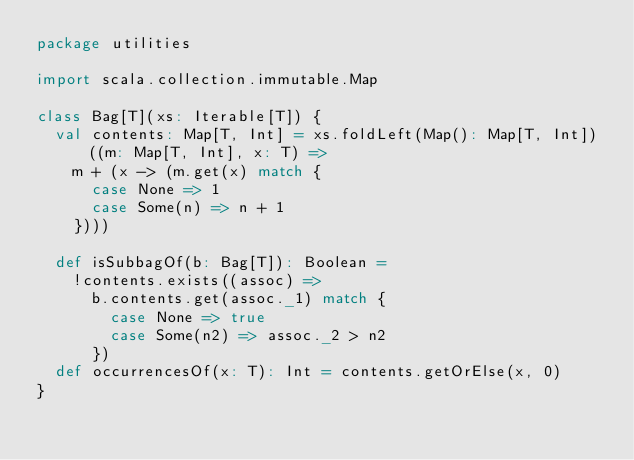Convert code to text. <code><loc_0><loc_0><loc_500><loc_500><_Scala_>package utilities

import scala.collection.immutable.Map

class Bag[T](xs: Iterable[T]) {
  val contents: Map[T, Int] = xs.foldLeft(Map(): Map[T, Int])((m: Map[T, Int], x: T) =>
    m + (x -> (m.get(x) match {
      case None => 1
      case Some(n) => n + 1
    })))

  def isSubbagOf(b: Bag[T]): Boolean =
    !contents.exists((assoc) =>
      b.contents.get(assoc._1) match {
        case None => true
        case Some(n2) => assoc._2 > n2
      })
  def occurrencesOf(x: T): Int = contents.getOrElse(x, 0)
}
</code> 